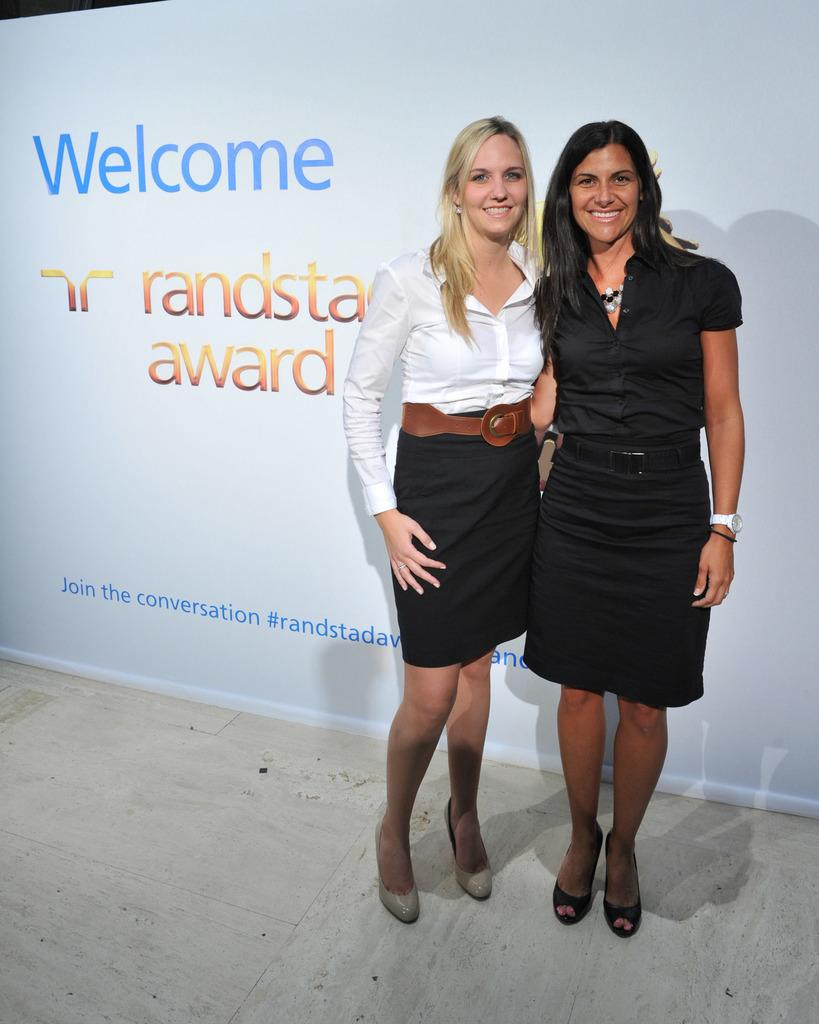How many people are in the image? There are two persons in the image. What are the persons doing in the image? The persons are standing and smiling. What can be seen in the background of the image? There is a board visible in the background of the image. How many bears are visible in the image? There are no bears present in the image. What type of girl can be seen in the image? There is no girl present in the image; it features two persons, both of whom appear to be adults. 